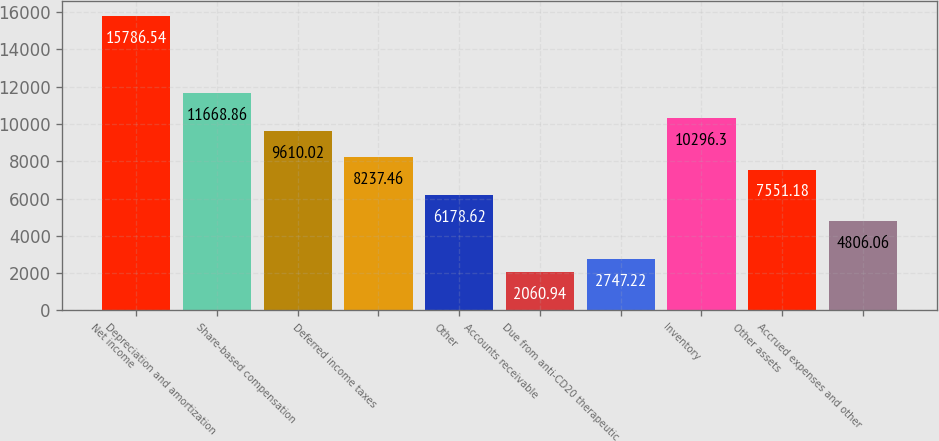Convert chart. <chart><loc_0><loc_0><loc_500><loc_500><bar_chart><fcel>Net income<fcel>Depreciation and amortization<fcel>Share-based compensation<fcel>Deferred income taxes<fcel>Other<fcel>Accounts receivable<fcel>Due from anti-CD20 therapeutic<fcel>Inventory<fcel>Other assets<fcel>Accrued expenses and other<nl><fcel>15786.5<fcel>11668.9<fcel>9610.02<fcel>8237.46<fcel>6178.62<fcel>2060.94<fcel>2747.22<fcel>10296.3<fcel>7551.18<fcel>4806.06<nl></chart> 